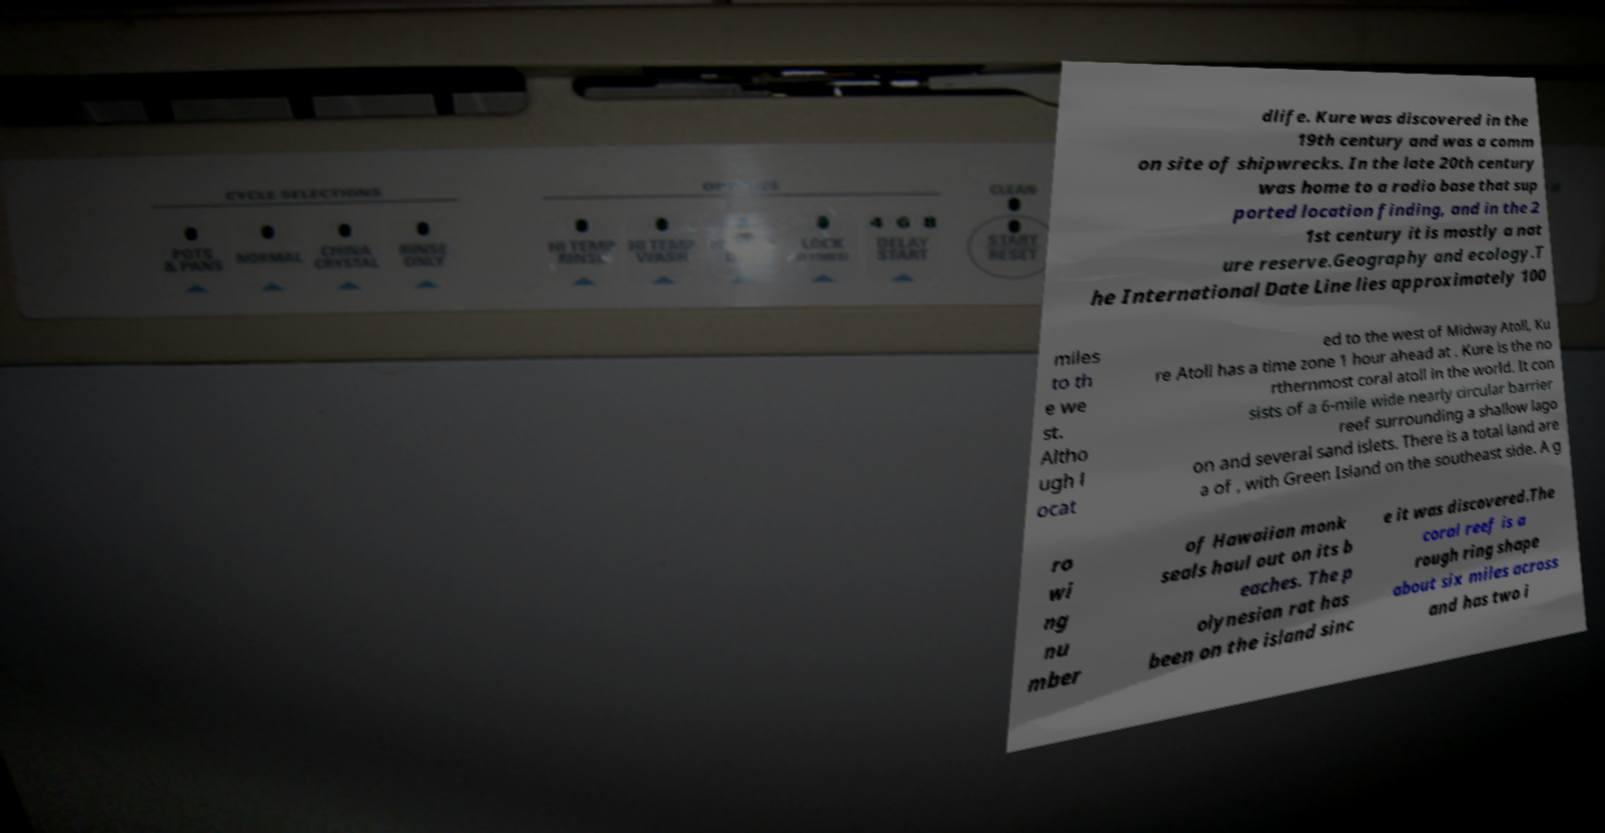Please identify and transcribe the text found in this image. dlife. Kure was discovered in the 19th century and was a comm on site of shipwrecks. In the late 20th century was home to a radio base that sup ported location finding, and in the 2 1st century it is mostly a nat ure reserve.Geography and ecology.T he International Date Line lies approximately 100 miles to th e we st. Altho ugh l ocat ed to the west of Midway Atoll, Ku re Atoll has a time zone 1 hour ahead at . Kure is the no rthernmost coral atoll in the world. It con sists of a 6-mile wide nearly circular barrier reef surrounding a shallow lago on and several sand islets. There is a total land are a of , with Green Island on the southeast side. A g ro wi ng nu mber of Hawaiian monk seals haul out on its b eaches. The p olynesian rat has been on the island sinc e it was discovered.The coral reef is a rough ring shape about six miles across and has two i 